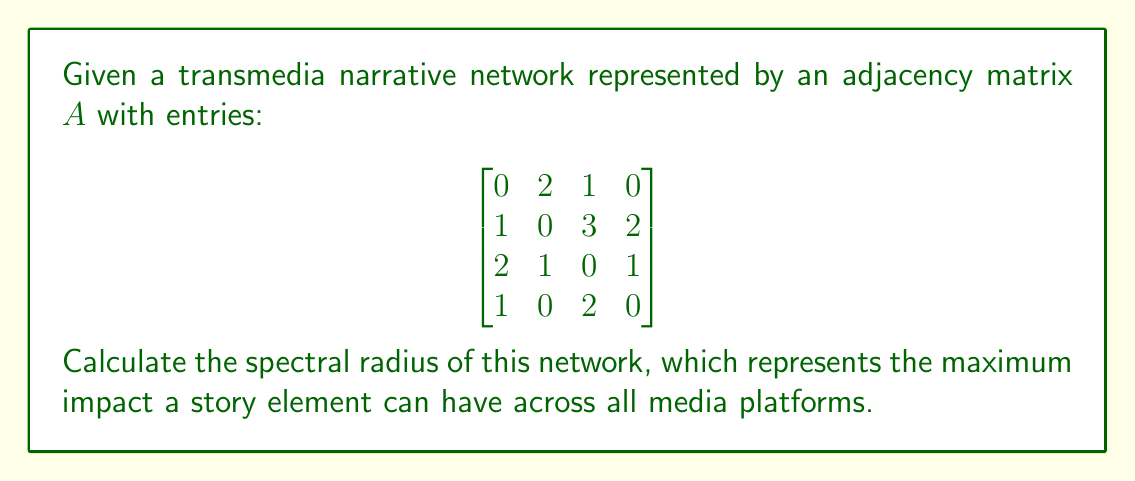Teach me how to tackle this problem. To calculate the spectral radius of the transmedia narrative network:

1) The spectral radius is the largest absolute value of the eigenvalues of matrix $A$.

2) To find eigenvalues, solve the characteristic equation:
   $det(A - \lambda I) = 0$

3) Expand the determinant:
   $$\begin{vmatrix}
   -\lambda & 2 & 1 & 0 \\
   1 & -\lambda & 3 & 2 \\
   2 & 1 & -\lambda & 1 \\
   1 & 0 & 2 & -\lambda
   \end{vmatrix} = 0$$

4) This yields the characteristic polynomial:
   $\lambda^4 - 21\lambda^2 - 18\lambda + 54 = 0$

5) Solving this equation gives the eigenvalues:
   $\lambda_1 \approx 4.2915$
   $\lambda_2 \approx -3.0432$
   $\lambda_3 \approx 1.3758$
   $\lambda_4 \approx -2.6241$

6) The spectral radius is the largest absolute value among these:
   $\rho(A) = |\lambda_1| \approx 4.2915$

This value represents the maximum potential impact or reach of a story element in the transmedia narrative network.
Answer: $4.2915$ 